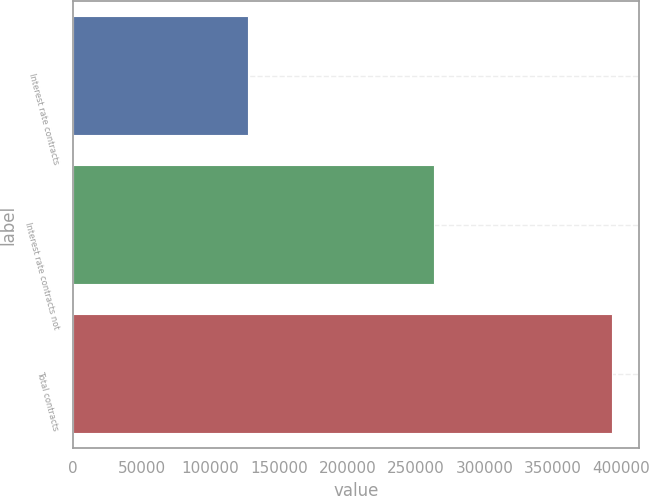<chart> <loc_0><loc_0><loc_500><loc_500><bar_chart><fcel>Interest rate contracts<fcel>Interest rate contracts not<fcel>Total contracts<nl><fcel>127346<fcel>263015<fcel>393206<nl></chart> 